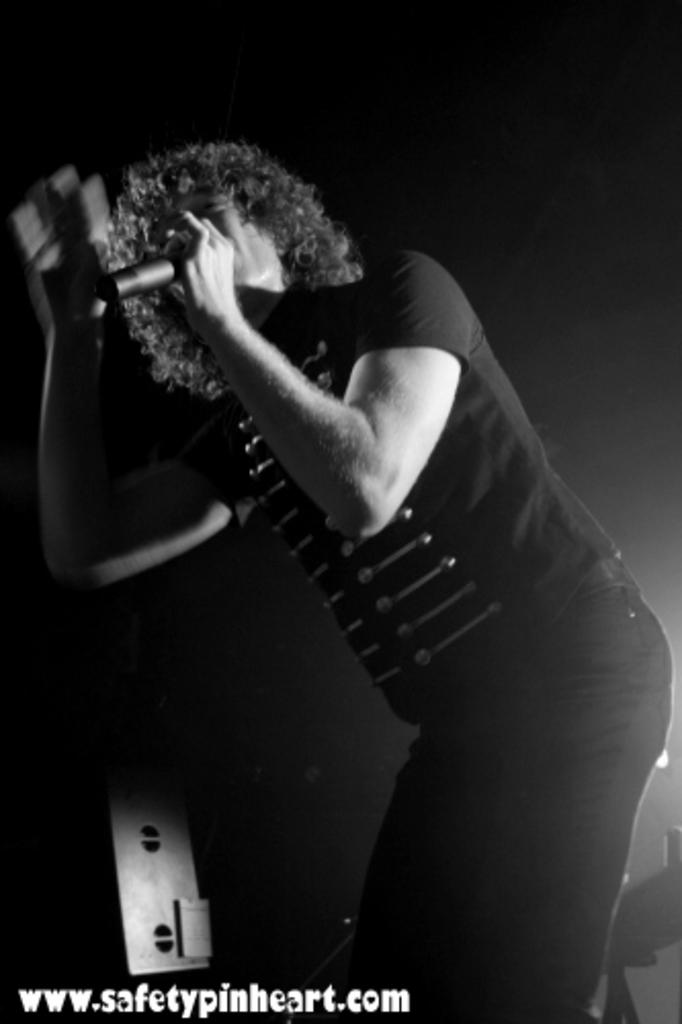What is the main subject of the image? There is a person in the image. What is the person holding in the image? The person is holding a microphone. What color is the background of the image? The background of the image is black. What type of science experiment is being conducted with the bulb in the image? There is no bulb present in the image, and therefore no science experiment can be observed. Is the person wearing a hat in the image? There is no mention of a hat in the image, so it cannot be determined whether the person is wearing one or not. 